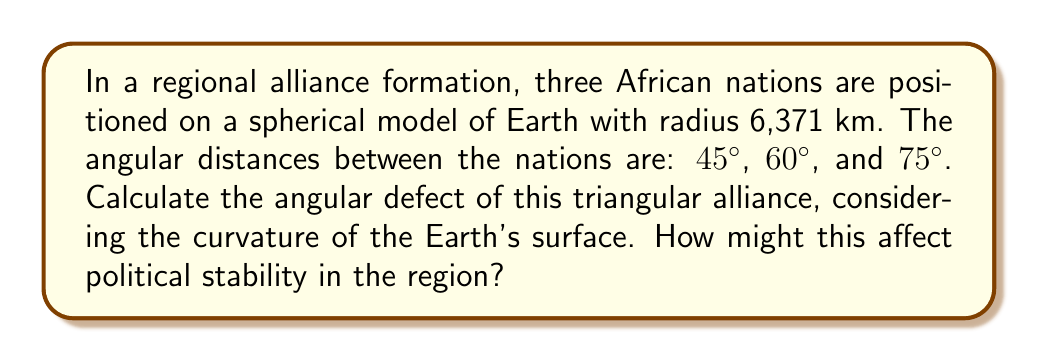Help me with this question. As a skeptical political analyst, let's approach this problem step-by-step:

1) In spherical geometry, the sum of angles in a triangle is always greater than 180°. The difference between this sum and 180° is called the angular defect.

2) The formula for angular defect (E) on a sphere is:

   $$E = A + B + C - 180°$$

   where A, B, and C are the angles of the spherical triangle.

3) We're given the side lengths (as angles) but not the angles themselves. We need to use the spherical law of cosines:

   $$\cos(a) = \cos(b)\cos(c) + \sin(b)\sin(c)\cos(A)$$

   where a, b, c are side lengths (in radians) and A is the opposite angle.

4) Let's calculate angle A (opposite to the 75° side):

   $$\cos(75°) = \cos(45°)\cos(60°) + \sin(45°)\sin(60°)\cos(A)$$

5) Solving for A:

   $$A = \arccos(\frac{\cos(75°) - \cos(45°)\cos(60°)}{\sin(45°)\sin(60°)}) \approx 82.82°$$

6) Similarly, we can calculate B (opposite to 60°) and C (opposite to 45°):

   B ≈ 69.52°
   C ≈ 53.13°

7) Now we can calculate the angular defect:

   $$E = 82.82° + 69.52° + 53.13° - 180° = 25.47°$$

8) To convert this to area, we use the formula:

   $$\text{Area} = E \cdot R^2$$

   where R is the radius of the sphere (Earth in this case).

9) $$\text{Area} = 25.47° \cdot (\frac{\pi}{180°}) \cdot (6371 \text{ km})^2 \approx 10,270,000 \text{ km}^2$$

This significant angular defect indicates a large spherical excess, which could symbolize potential tensions or instabilities in the alliance due to the vast area involved.
Answer: 25.47° 